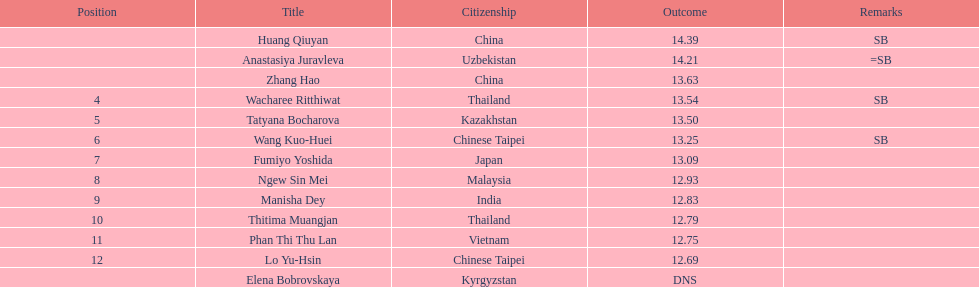How do the results of huang qiuyan and fumiyo yoshida differ? 1.3. 